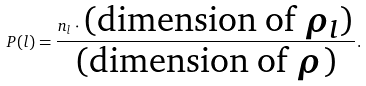Convert formula to latex. <formula><loc_0><loc_0><loc_500><loc_500>P ( l ) = \frac { n _ { l } \cdot \text {(dimension of $\rho_{l}$)} } { \text {(dimension of $\rho$)} } .</formula> 